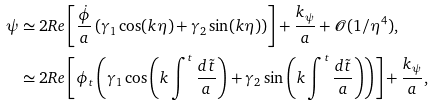<formula> <loc_0><loc_0><loc_500><loc_500>\psi & \simeq 2 R e \left [ \frac { \dot { \phi } } { a } \left ( \gamma _ { 1 } \cos ( k \eta ) + \gamma _ { 2 } \sin ( k \eta ) \right ) \right ] + \frac { k _ { \psi } } { a } + \mathcal { O } ( 1 / \eta ^ { 4 } ) , \\ & \simeq 2 R e \left [ \phi _ { t } \left ( \gamma _ { 1 } \cos \left ( k \int ^ { t } \frac { d \tilde { t } } { a } \right ) + \gamma _ { 2 } \sin \left ( k \int ^ { t } \frac { d \tilde { t } } { a } \right ) \right ) \right ] + \frac { k _ { \psi } } { a } ,</formula> 